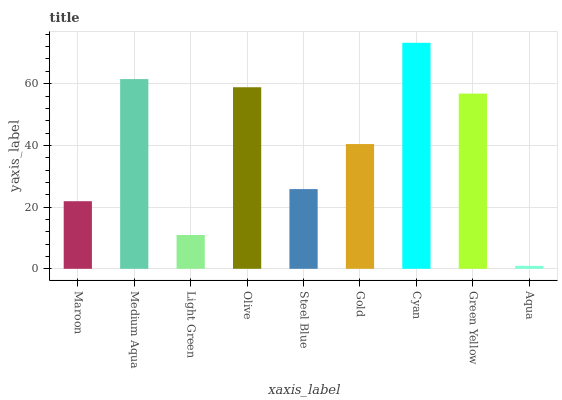Is Aqua the minimum?
Answer yes or no. Yes. Is Cyan the maximum?
Answer yes or no. Yes. Is Medium Aqua the minimum?
Answer yes or no. No. Is Medium Aqua the maximum?
Answer yes or no. No. Is Medium Aqua greater than Maroon?
Answer yes or no. Yes. Is Maroon less than Medium Aqua?
Answer yes or no. Yes. Is Maroon greater than Medium Aqua?
Answer yes or no. No. Is Medium Aqua less than Maroon?
Answer yes or no. No. Is Gold the high median?
Answer yes or no. Yes. Is Gold the low median?
Answer yes or no. Yes. Is Green Yellow the high median?
Answer yes or no. No. Is Olive the low median?
Answer yes or no. No. 